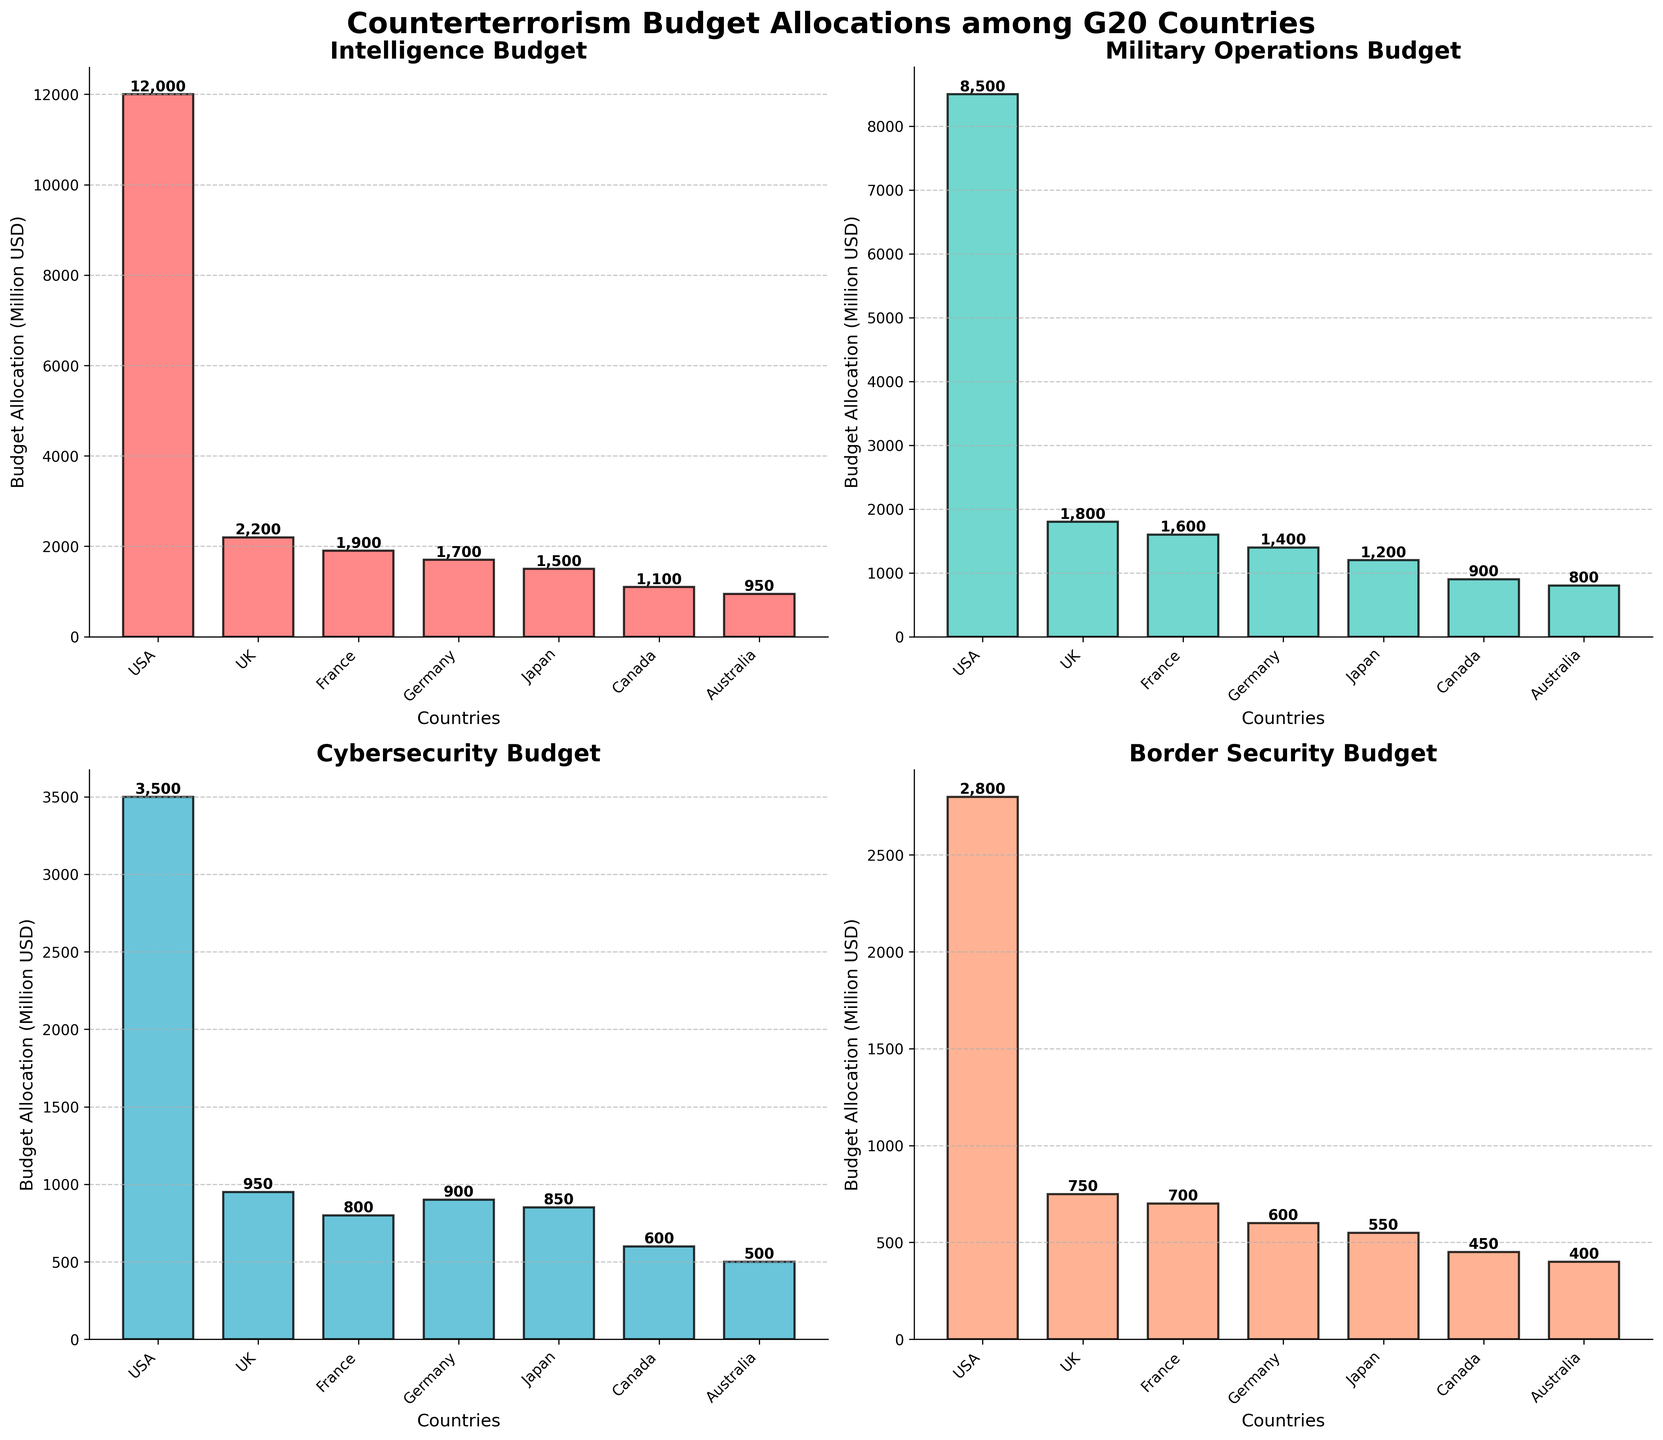What is the title of the figure? The title is located at the top of the figure and generally provides a succinct summary of what the figure shows. In this case, it's formatted in a larger and bold font.
Answer: Counterterrorism Budget Allocations among G20 Countries How many subplots are there in the figure, and what categories do they represent? The figure is divided into four subplots, each titled differently according to the budget category it represents. These can be found by looking at the section titles.
Answer: Four subplots: Intelligence, Military Operations, Cybersecurity, Border Security Which country has the highest budget allocation in the 'Military Operations' category? By examining the 'Military Operations Budget' subplot, it's visible that the tallest bar represents the USA, indicating the highest budget allocation for this category.
Answer: USA How does Japan's budget allocation for 'Cybersecurity' compare to France's in the same category? To compare, check the heights of the bars for Japan and France in the 'Cybersecurity Budget' subplot. Japan's bar is slightly taller than France's.
Answer: Japan's is higher What's the total budget allocation for 'Intelligence' across all countries shown? To find the total, sum the heights of the bars in the 'Intelligence Budget' subplot for all countries. Calculate as follows: 12000 (USA) + 2200 (UK) + 1900 (France) + 1700 (Germany) + 1500 (Japan) + 1100 (Canada) + 950 (Australia).
Answer: 22,350 million USD Which category has the lowest budget allocation for Australia? Check each subplot to find Australia's smallest bar, which is in the 'Border Security Budget' subplot.
Answer: Border Security Compare the budget allocations for the 'Border Security' category in the USA and Canada. What is the difference? Identify the heights of the bars for the USA and Canada in the 'Border Security Budget' subplot. The calculation is 2800 (USA) - 450 (Canada).
Answer: 2,350 million USD What is the average budget allocation for 'Cybersecurity' across all countries? Sum the values of all 'Cybersecurity' bars across all countries and divide by the number of countries (7). Calculation: (3500 + 950 + 800 + 900 + 850 + 600 + 500) / 7.
Answer: 1,300 million USD Which country has the second highest budget allocation for 'Intelligence'? Examine the 'Intelligence Budget' subplot and compare the heights of the bars. The USA has the highest, and the UK has the second highest.
Answer: UK 